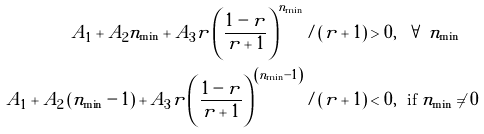<formula> <loc_0><loc_0><loc_500><loc_500>A _ { 1 } + A _ { 2 } n _ { \min } + A _ { 3 } r \left ( \frac { 1 - r } { r + 1 } \right ) ^ { n _ { \min } } / \left ( r + 1 \right ) & > 0 , \text { \ } \forall \text { } n _ { \min } \\ A _ { 1 } + A _ { 2 } \left ( n _ { \min } - 1 \right ) + A _ { 3 } r \left ( \frac { 1 - r } { r + 1 } \right ) ^ { \left ( n _ { \min } - 1 \right ) } / \left ( r + 1 \right ) & < 0 , \text { \ if } n _ { \min } \neq 0</formula> 